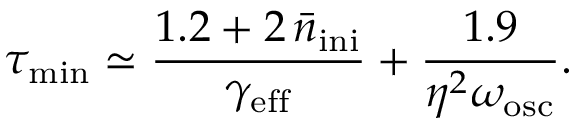<formula> <loc_0><loc_0><loc_500><loc_500>\tau _ { \min } \simeq \frac { 1 . 2 + 2 \, \bar { n } _ { i n i } } { \gamma _ { e f f } } + \frac { 1 . 9 } { \eta ^ { 2 } \omega _ { o s c } } .</formula> 